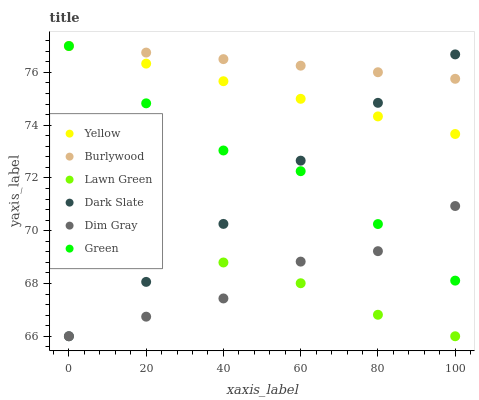Does Lawn Green have the minimum area under the curve?
Answer yes or no. Yes. Does Burlywood have the maximum area under the curve?
Answer yes or no. Yes. Does Dim Gray have the minimum area under the curve?
Answer yes or no. No. Does Dim Gray have the maximum area under the curve?
Answer yes or no. No. Is Yellow the smoothest?
Answer yes or no. Yes. Is Dim Gray the roughest?
Answer yes or no. Yes. Is Burlywood the smoothest?
Answer yes or no. No. Is Burlywood the roughest?
Answer yes or no. No. Does Lawn Green have the lowest value?
Answer yes or no. Yes. Does Burlywood have the lowest value?
Answer yes or no. No. Does Green have the highest value?
Answer yes or no. Yes. Does Dim Gray have the highest value?
Answer yes or no. No. Is Dim Gray less than Yellow?
Answer yes or no. Yes. Is Green greater than Lawn Green?
Answer yes or no. Yes. Does Dark Slate intersect Lawn Green?
Answer yes or no. Yes. Is Dark Slate less than Lawn Green?
Answer yes or no. No. Is Dark Slate greater than Lawn Green?
Answer yes or no. No. Does Dim Gray intersect Yellow?
Answer yes or no. No. 